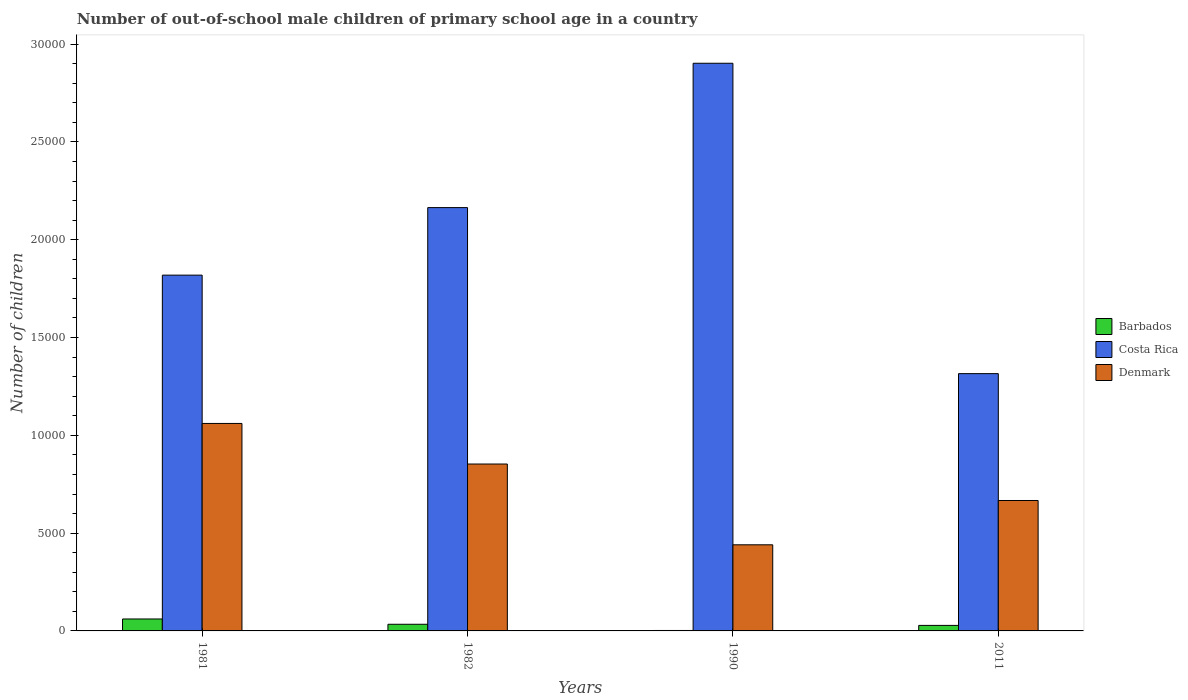Are the number of bars per tick equal to the number of legend labels?
Offer a terse response. Yes. Are the number of bars on each tick of the X-axis equal?
Your answer should be compact. Yes. What is the number of out-of-school male children in Costa Rica in 1981?
Provide a short and direct response. 1.82e+04. Across all years, what is the maximum number of out-of-school male children in Denmark?
Provide a short and direct response. 1.06e+04. Across all years, what is the minimum number of out-of-school male children in Denmark?
Ensure brevity in your answer.  4403. In which year was the number of out-of-school male children in Barbados maximum?
Your answer should be very brief. 1981. What is the total number of out-of-school male children in Denmark in the graph?
Provide a succinct answer. 3.02e+04. What is the difference between the number of out-of-school male children in Denmark in 1981 and that in 2011?
Provide a short and direct response. 3939. What is the difference between the number of out-of-school male children in Costa Rica in 1981 and the number of out-of-school male children in Barbados in 1990?
Keep it short and to the point. 1.82e+04. What is the average number of out-of-school male children in Costa Rica per year?
Offer a very short reply. 2.05e+04. In the year 1981, what is the difference between the number of out-of-school male children in Denmark and number of out-of-school male children in Costa Rica?
Offer a terse response. -7583. What is the ratio of the number of out-of-school male children in Costa Rica in 1981 to that in 1990?
Provide a short and direct response. 0.63. What is the difference between the highest and the second highest number of out-of-school male children in Denmark?
Keep it short and to the point. 2075. What is the difference between the highest and the lowest number of out-of-school male children in Denmark?
Provide a succinct answer. 6205. In how many years, is the number of out-of-school male children in Costa Rica greater than the average number of out-of-school male children in Costa Rica taken over all years?
Provide a short and direct response. 2. What does the 3rd bar from the left in 2011 represents?
Provide a succinct answer. Denmark. What does the 3rd bar from the right in 2011 represents?
Your response must be concise. Barbados. How many bars are there?
Provide a short and direct response. 12. What is the difference between two consecutive major ticks on the Y-axis?
Offer a very short reply. 5000. Are the values on the major ticks of Y-axis written in scientific E-notation?
Provide a succinct answer. No. Does the graph contain any zero values?
Provide a short and direct response. No. What is the title of the graph?
Your answer should be compact. Number of out-of-school male children of primary school age in a country. Does "Haiti" appear as one of the legend labels in the graph?
Your answer should be very brief. No. What is the label or title of the X-axis?
Offer a very short reply. Years. What is the label or title of the Y-axis?
Offer a very short reply. Number of children. What is the Number of children in Barbados in 1981?
Your answer should be very brief. 611. What is the Number of children in Costa Rica in 1981?
Your answer should be compact. 1.82e+04. What is the Number of children in Denmark in 1981?
Give a very brief answer. 1.06e+04. What is the Number of children of Barbados in 1982?
Your answer should be very brief. 340. What is the Number of children of Costa Rica in 1982?
Offer a terse response. 2.16e+04. What is the Number of children of Denmark in 1982?
Your answer should be compact. 8533. What is the Number of children in Costa Rica in 1990?
Ensure brevity in your answer.  2.90e+04. What is the Number of children of Denmark in 1990?
Your response must be concise. 4403. What is the Number of children of Barbados in 2011?
Your response must be concise. 282. What is the Number of children of Costa Rica in 2011?
Your answer should be very brief. 1.32e+04. What is the Number of children of Denmark in 2011?
Your response must be concise. 6669. Across all years, what is the maximum Number of children of Barbados?
Your answer should be compact. 611. Across all years, what is the maximum Number of children in Costa Rica?
Your answer should be very brief. 2.90e+04. Across all years, what is the maximum Number of children of Denmark?
Provide a succinct answer. 1.06e+04. Across all years, what is the minimum Number of children of Costa Rica?
Provide a short and direct response. 1.32e+04. Across all years, what is the minimum Number of children of Denmark?
Your answer should be compact. 4403. What is the total Number of children in Barbados in the graph?
Your answer should be compact. 1256. What is the total Number of children of Costa Rica in the graph?
Make the answer very short. 8.20e+04. What is the total Number of children of Denmark in the graph?
Provide a succinct answer. 3.02e+04. What is the difference between the Number of children in Barbados in 1981 and that in 1982?
Your response must be concise. 271. What is the difference between the Number of children of Costa Rica in 1981 and that in 1982?
Your answer should be very brief. -3453. What is the difference between the Number of children of Denmark in 1981 and that in 1982?
Give a very brief answer. 2075. What is the difference between the Number of children in Barbados in 1981 and that in 1990?
Provide a short and direct response. 588. What is the difference between the Number of children of Costa Rica in 1981 and that in 1990?
Your answer should be very brief. -1.08e+04. What is the difference between the Number of children of Denmark in 1981 and that in 1990?
Provide a succinct answer. 6205. What is the difference between the Number of children of Barbados in 1981 and that in 2011?
Your answer should be very brief. 329. What is the difference between the Number of children in Costa Rica in 1981 and that in 2011?
Make the answer very short. 5036. What is the difference between the Number of children of Denmark in 1981 and that in 2011?
Your answer should be very brief. 3939. What is the difference between the Number of children of Barbados in 1982 and that in 1990?
Provide a short and direct response. 317. What is the difference between the Number of children in Costa Rica in 1982 and that in 1990?
Provide a short and direct response. -7380. What is the difference between the Number of children in Denmark in 1982 and that in 1990?
Offer a terse response. 4130. What is the difference between the Number of children of Barbados in 1982 and that in 2011?
Keep it short and to the point. 58. What is the difference between the Number of children in Costa Rica in 1982 and that in 2011?
Your response must be concise. 8489. What is the difference between the Number of children of Denmark in 1982 and that in 2011?
Ensure brevity in your answer.  1864. What is the difference between the Number of children of Barbados in 1990 and that in 2011?
Your answer should be very brief. -259. What is the difference between the Number of children of Costa Rica in 1990 and that in 2011?
Offer a terse response. 1.59e+04. What is the difference between the Number of children in Denmark in 1990 and that in 2011?
Keep it short and to the point. -2266. What is the difference between the Number of children in Barbados in 1981 and the Number of children in Costa Rica in 1982?
Provide a succinct answer. -2.10e+04. What is the difference between the Number of children in Barbados in 1981 and the Number of children in Denmark in 1982?
Offer a very short reply. -7922. What is the difference between the Number of children of Costa Rica in 1981 and the Number of children of Denmark in 1982?
Make the answer very short. 9658. What is the difference between the Number of children in Barbados in 1981 and the Number of children in Costa Rica in 1990?
Provide a succinct answer. -2.84e+04. What is the difference between the Number of children of Barbados in 1981 and the Number of children of Denmark in 1990?
Keep it short and to the point. -3792. What is the difference between the Number of children of Costa Rica in 1981 and the Number of children of Denmark in 1990?
Ensure brevity in your answer.  1.38e+04. What is the difference between the Number of children in Barbados in 1981 and the Number of children in Costa Rica in 2011?
Make the answer very short. -1.25e+04. What is the difference between the Number of children in Barbados in 1981 and the Number of children in Denmark in 2011?
Ensure brevity in your answer.  -6058. What is the difference between the Number of children in Costa Rica in 1981 and the Number of children in Denmark in 2011?
Offer a terse response. 1.15e+04. What is the difference between the Number of children of Barbados in 1982 and the Number of children of Costa Rica in 1990?
Your answer should be very brief. -2.87e+04. What is the difference between the Number of children of Barbados in 1982 and the Number of children of Denmark in 1990?
Your answer should be compact. -4063. What is the difference between the Number of children in Costa Rica in 1982 and the Number of children in Denmark in 1990?
Your answer should be compact. 1.72e+04. What is the difference between the Number of children in Barbados in 1982 and the Number of children in Costa Rica in 2011?
Keep it short and to the point. -1.28e+04. What is the difference between the Number of children of Barbados in 1982 and the Number of children of Denmark in 2011?
Your answer should be compact. -6329. What is the difference between the Number of children of Costa Rica in 1982 and the Number of children of Denmark in 2011?
Your response must be concise. 1.50e+04. What is the difference between the Number of children in Barbados in 1990 and the Number of children in Costa Rica in 2011?
Your answer should be compact. -1.31e+04. What is the difference between the Number of children of Barbados in 1990 and the Number of children of Denmark in 2011?
Offer a terse response. -6646. What is the difference between the Number of children of Costa Rica in 1990 and the Number of children of Denmark in 2011?
Offer a very short reply. 2.24e+04. What is the average Number of children in Barbados per year?
Make the answer very short. 314. What is the average Number of children in Costa Rica per year?
Keep it short and to the point. 2.05e+04. What is the average Number of children of Denmark per year?
Provide a short and direct response. 7553.25. In the year 1981, what is the difference between the Number of children of Barbados and Number of children of Costa Rica?
Keep it short and to the point. -1.76e+04. In the year 1981, what is the difference between the Number of children of Barbados and Number of children of Denmark?
Give a very brief answer. -9997. In the year 1981, what is the difference between the Number of children of Costa Rica and Number of children of Denmark?
Keep it short and to the point. 7583. In the year 1982, what is the difference between the Number of children in Barbados and Number of children in Costa Rica?
Keep it short and to the point. -2.13e+04. In the year 1982, what is the difference between the Number of children in Barbados and Number of children in Denmark?
Make the answer very short. -8193. In the year 1982, what is the difference between the Number of children in Costa Rica and Number of children in Denmark?
Offer a very short reply. 1.31e+04. In the year 1990, what is the difference between the Number of children in Barbados and Number of children in Costa Rica?
Give a very brief answer. -2.90e+04. In the year 1990, what is the difference between the Number of children in Barbados and Number of children in Denmark?
Ensure brevity in your answer.  -4380. In the year 1990, what is the difference between the Number of children in Costa Rica and Number of children in Denmark?
Offer a very short reply. 2.46e+04. In the year 2011, what is the difference between the Number of children of Barbados and Number of children of Costa Rica?
Offer a very short reply. -1.29e+04. In the year 2011, what is the difference between the Number of children in Barbados and Number of children in Denmark?
Your response must be concise. -6387. In the year 2011, what is the difference between the Number of children in Costa Rica and Number of children in Denmark?
Offer a terse response. 6486. What is the ratio of the Number of children in Barbados in 1981 to that in 1982?
Provide a succinct answer. 1.8. What is the ratio of the Number of children of Costa Rica in 1981 to that in 1982?
Keep it short and to the point. 0.84. What is the ratio of the Number of children in Denmark in 1981 to that in 1982?
Offer a terse response. 1.24. What is the ratio of the Number of children in Barbados in 1981 to that in 1990?
Your response must be concise. 26.57. What is the ratio of the Number of children in Costa Rica in 1981 to that in 1990?
Provide a succinct answer. 0.63. What is the ratio of the Number of children of Denmark in 1981 to that in 1990?
Make the answer very short. 2.41. What is the ratio of the Number of children in Barbados in 1981 to that in 2011?
Ensure brevity in your answer.  2.17. What is the ratio of the Number of children in Costa Rica in 1981 to that in 2011?
Your answer should be compact. 1.38. What is the ratio of the Number of children of Denmark in 1981 to that in 2011?
Keep it short and to the point. 1.59. What is the ratio of the Number of children in Barbados in 1982 to that in 1990?
Provide a succinct answer. 14.78. What is the ratio of the Number of children of Costa Rica in 1982 to that in 1990?
Your answer should be compact. 0.75. What is the ratio of the Number of children in Denmark in 1982 to that in 1990?
Make the answer very short. 1.94. What is the ratio of the Number of children in Barbados in 1982 to that in 2011?
Your answer should be compact. 1.21. What is the ratio of the Number of children in Costa Rica in 1982 to that in 2011?
Make the answer very short. 1.65. What is the ratio of the Number of children in Denmark in 1982 to that in 2011?
Keep it short and to the point. 1.28. What is the ratio of the Number of children in Barbados in 1990 to that in 2011?
Make the answer very short. 0.08. What is the ratio of the Number of children in Costa Rica in 1990 to that in 2011?
Provide a short and direct response. 2.21. What is the ratio of the Number of children in Denmark in 1990 to that in 2011?
Your answer should be very brief. 0.66. What is the difference between the highest and the second highest Number of children in Barbados?
Your answer should be very brief. 271. What is the difference between the highest and the second highest Number of children in Costa Rica?
Provide a succinct answer. 7380. What is the difference between the highest and the second highest Number of children of Denmark?
Keep it short and to the point. 2075. What is the difference between the highest and the lowest Number of children in Barbados?
Provide a succinct answer. 588. What is the difference between the highest and the lowest Number of children of Costa Rica?
Offer a terse response. 1.59e+04. What is the difference between the highest and the lowest Number of children in Denmark?
Offer a terse response. 6205. 